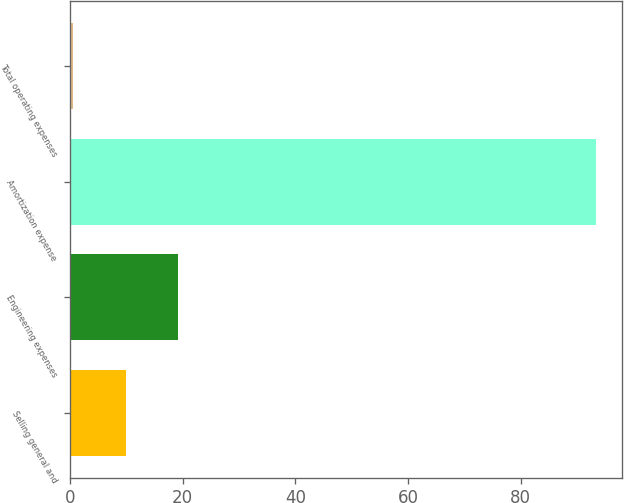Convert chart to OTSL. <chart><loc_0><loc_0><loc_500><loc_500><bar_chart><fcel>Selling general and<fcel>Engineering expenses<fcel>Amortization expense<fcel>Total operating expenses<nl><fcel>9.88<fcel>19.16<fcel>93.4<fcel>0.6<nl></chart> 